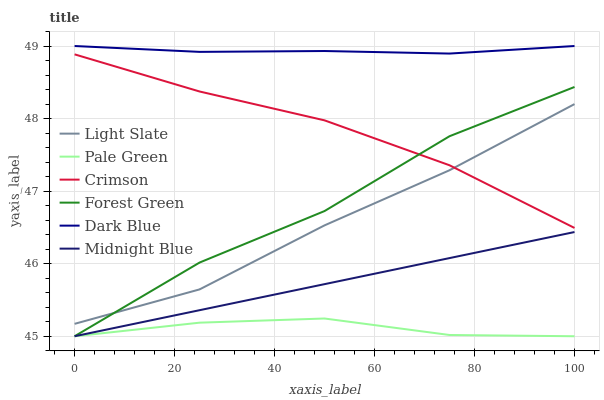Does Pale Green have the minimum area under the curve?
Answer yes or no. Yes. Does Dark Blue have the maximum area under the curve?
Answer yes or no. Yes. Does Light Slate have the minimum area under the curve?
Answer yes or no. No. Does Light Slate have the maximum area under the curve?
Answer yes or no. No. Is Midnight Blue the smoothest?
Answer yes or no. Yes. Is Forest Green the roughest?
Answer yes or no. Yes. Is Light Slate the smoothest?
Answer yes or no. No. Is Light Slate the roughest?
Answer yes or no. No. Does Midnight Blue have the lowest value?
Answer yes or no. Yes. Does Light Slate have the lowest value?
Answer yes or no. No. Does Dark Blue have the highest value?
Answer yes or no. Yes. Does Light Slate have the highest value?
Answer yes or no. No. Is Pale Green less than Light Slate?
Answer yes or no. Yes. Is Light Slate greater than Midnight Blue?
Answer yes or no. Yes. Does Pale Green intersect Forest Green?
Answer yes or no. Yes. Is Pale Green less than Forest Green?
Answer yes or no. No. Is Pale Green greater than Forest Green?
Answer yes or no. No. Does Pale Green intersect Light Slate?
Answer yes or no. No. 